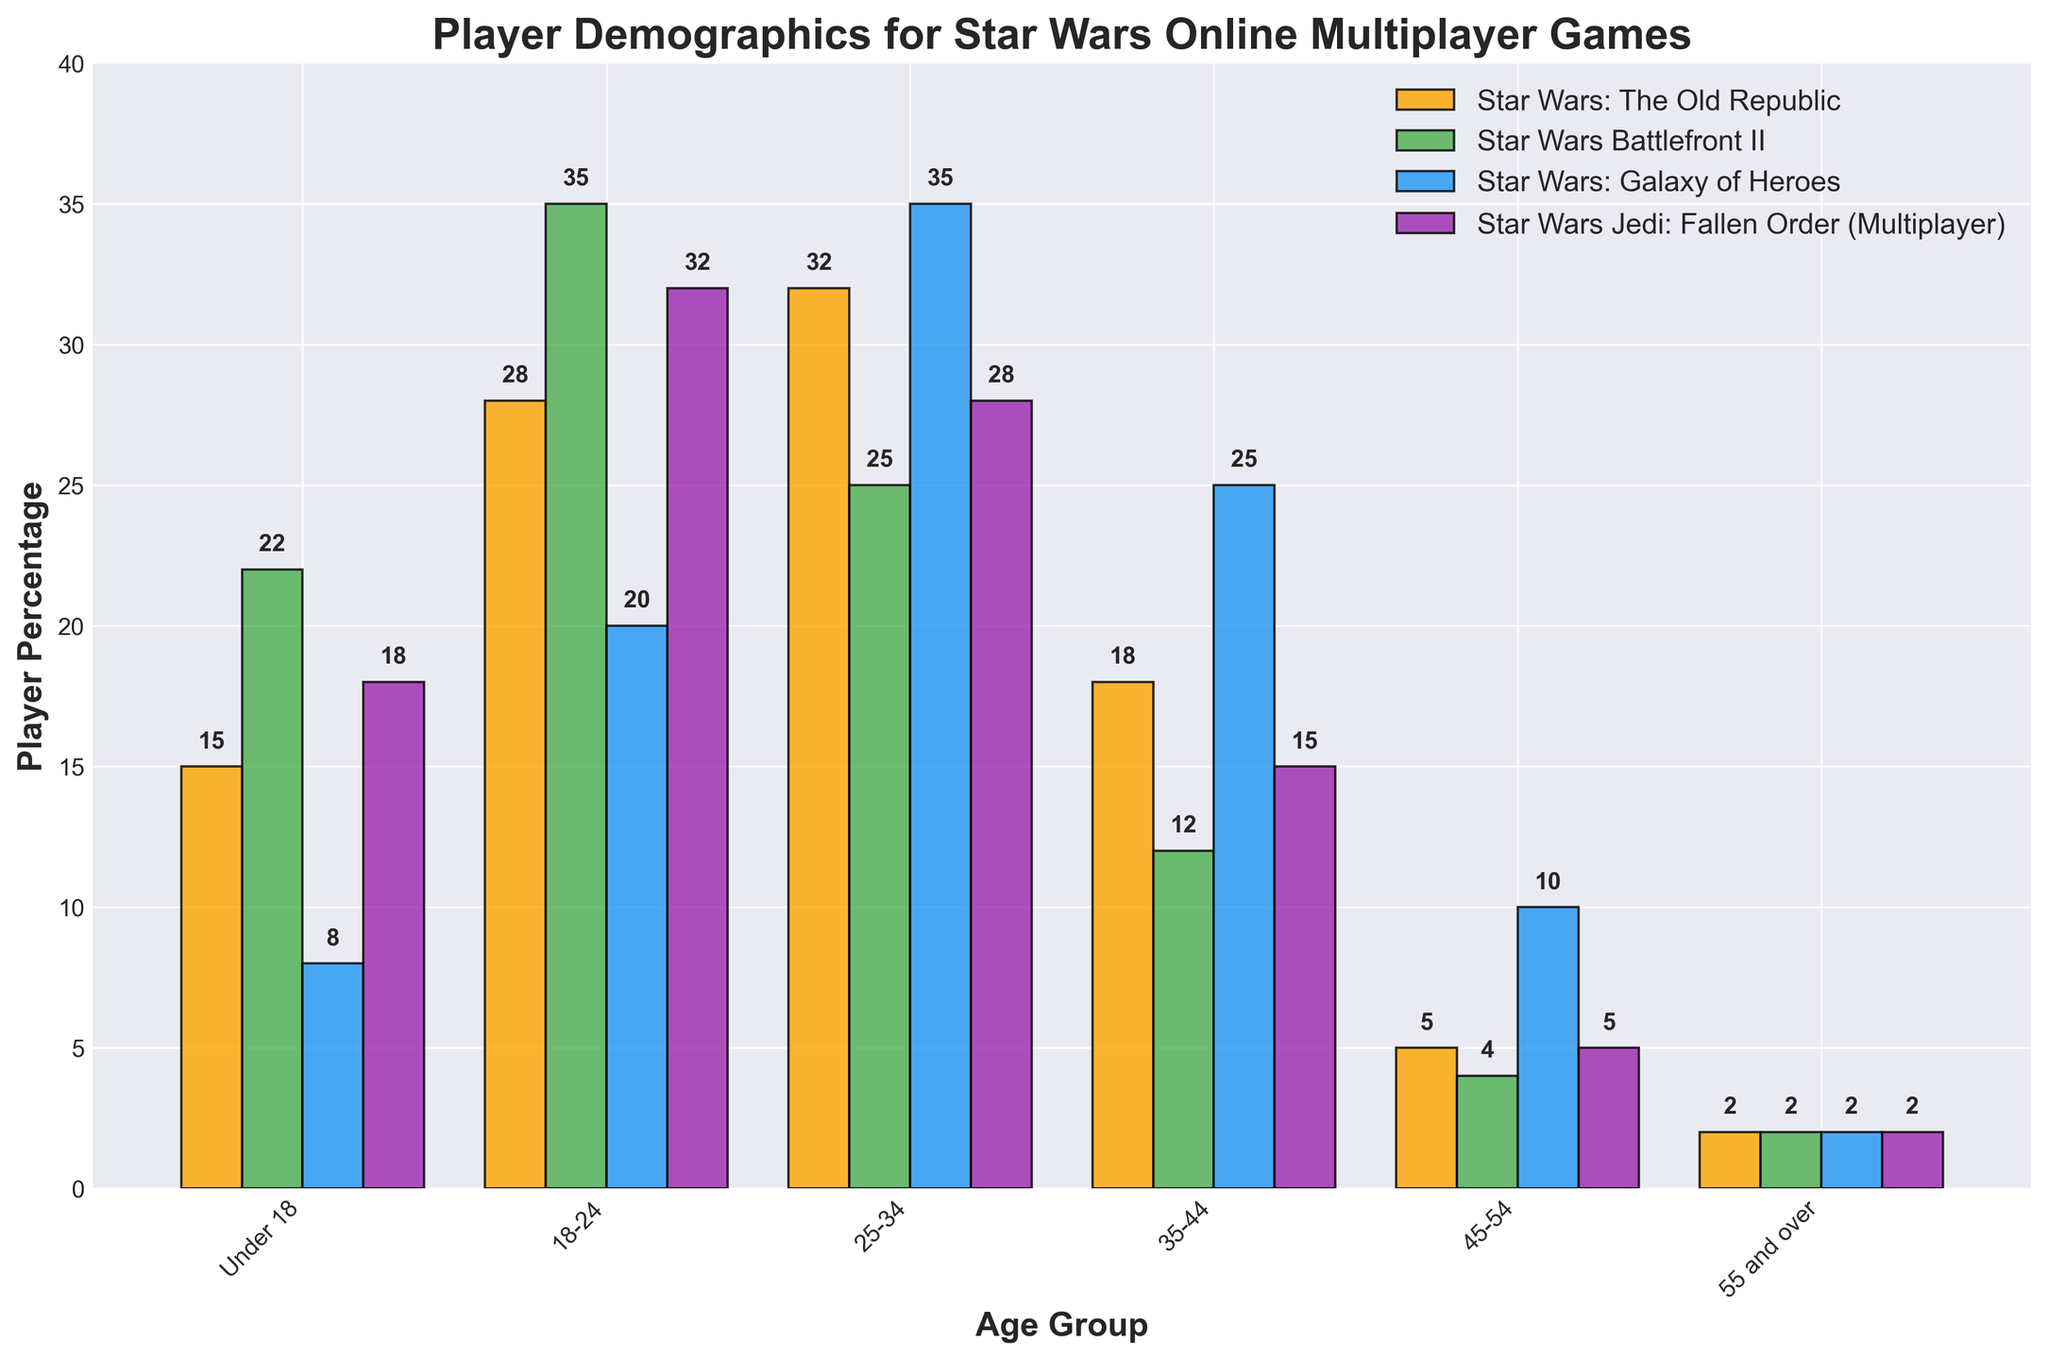Which game has the highest percentage of players aged 25-34? To determine the highest percentage of players in the 25-34 age group, we compare the heights of the bars for each game in this category. Star Wars: Galaxy of Heroes has the tallest bar at 35%.
Answer: Star Wars: Galaxy of Heroes What is the combined percentage of players aged under 18 for all games? Add the percentages of players under 18 for all four games: (15 for The Old Republic) + (22 for Battlefront II) + (8 for Galaxy of Heroes) + (18 for Jedi: Fallen Order). The sum is 15 + 22 + 8 + 18 = 63%.
Answer: 63% Which age group has the smallest combined percentage across all games? To find the smallest combined percentage, sum the percentages for each age group across all games and compare. The sums are: Under 18 (63), 18-24 (115), 25-34 (120), 35-44 (70), 45-54 (24), 55 and over (8). The 55 and over group has the smallest sum at 8%.
Answer: 55 and over Between Star Wars: The Old Republic and Star Wars Battlefront II, which game has a higher percentage of players aged 18-24? Compare the heights of the bars for the two games in the 18-24 category. Star Wars Battlefront II has a higher percentage at 35% compared to 28% for The Old Republic.
Answer: Star Wars Battlefront II In the age group 45-54, what is the exact difference in player percentage between Star Wars Battlefront II and Star Wars Jedi: Fallen Order? Subtract the percentage of players aged 45-54 in Star Wars Battlefront II (4) from the percentage for Star Wars Jedi: Fallen Order (5). The difference is 5 - 4 = 1%.
Answer: 1% What is the average percentage of players aged 35-44 across all games? Sum the percentages of players aged 35-44 across all four games and divide by the number of games. The sum is 18 (The Old Republic) + 12 (Battlefront II) + 25 (Galaxy of Heroes) + 15 (Jedi: Fallen Order) = 70. The average is 70 / 4 = 17.5%.
Answer: 17.5% Which game has the most evenly distributed player percentages across all age groups? Look at the bars' heights for each game across all age groups. Star Wars: Galaxy of Heroes appears to have the most even distribution with percentages relatively close to each other, ranging from 2% to 35%.
Answer: Star Wars: Galaxy of Heroes Which age group has the highest percentage of players for Star Wars Jedi: Fallen Order? Identify the tallest bar among the age groups for Star Wars Jedi: Fallen Order. The 18-24 age group, with a bar height of 32%, has the highest percentage.
Answer: 18-24 